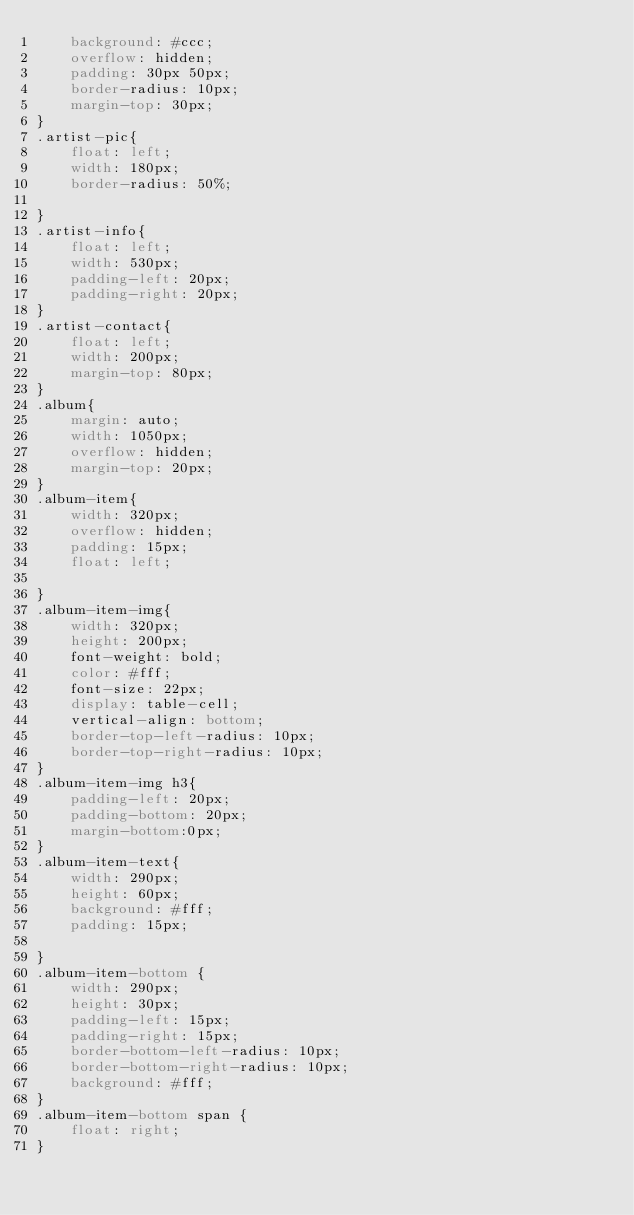<code> <loc_0><loc_0><loc_500><loc_500><_CSS_>    background: #ccc;
    overflow: hidden;
    padding: 30px 50px;
    border-radius: 10px;
    margin-top: 30px;
}
.artist-pic{
    float: left;
    width: 180px;
    border-radius: 50%;
    
}
.artist-info{
    float: left;
    width: 530px;
    padding-left: 20px;
    padding-right: 20px;
}
.artist-contact{
    float: left;
    width: 200px;
    margin-top: 80px;
}
.album{
    margin: auto;
    width: 1050px;
    overflow: hidden;
    margin-top: 20px;
}
.album-item{
    width: 320px;
    overflow: hidden;
    padding: 15px;
    float: left;

}
.album-item-img{
    width: 320px;
    height: 200px;
    font-weight: bold;
    color: #fff;
    font-size: 22px;
    display: table-cell;
    vertical-align: bottom;
    border-top-left-radius: 10px;
    border-top-right-radius: 10px;
}
.album-item-img h3{
    padding-left: 20px;
    padding-bottom: 20px;
    margin-bottom:0px;
}
.album-item-text{
    width: 290px;
    height: 60px;
    background: #fff;
    padding: 15px;
    
}
.album-item-bottom {
    width: 290px;
    height: 30px;
    padding-left: 15px;
    padding-right: 15px;
    border-bottom-left-radius: 10px;
    border-bottom-right-radius: 10px;
    background: #fff;
}
.album-item-bottom span {
    float: right;
}


</code> 